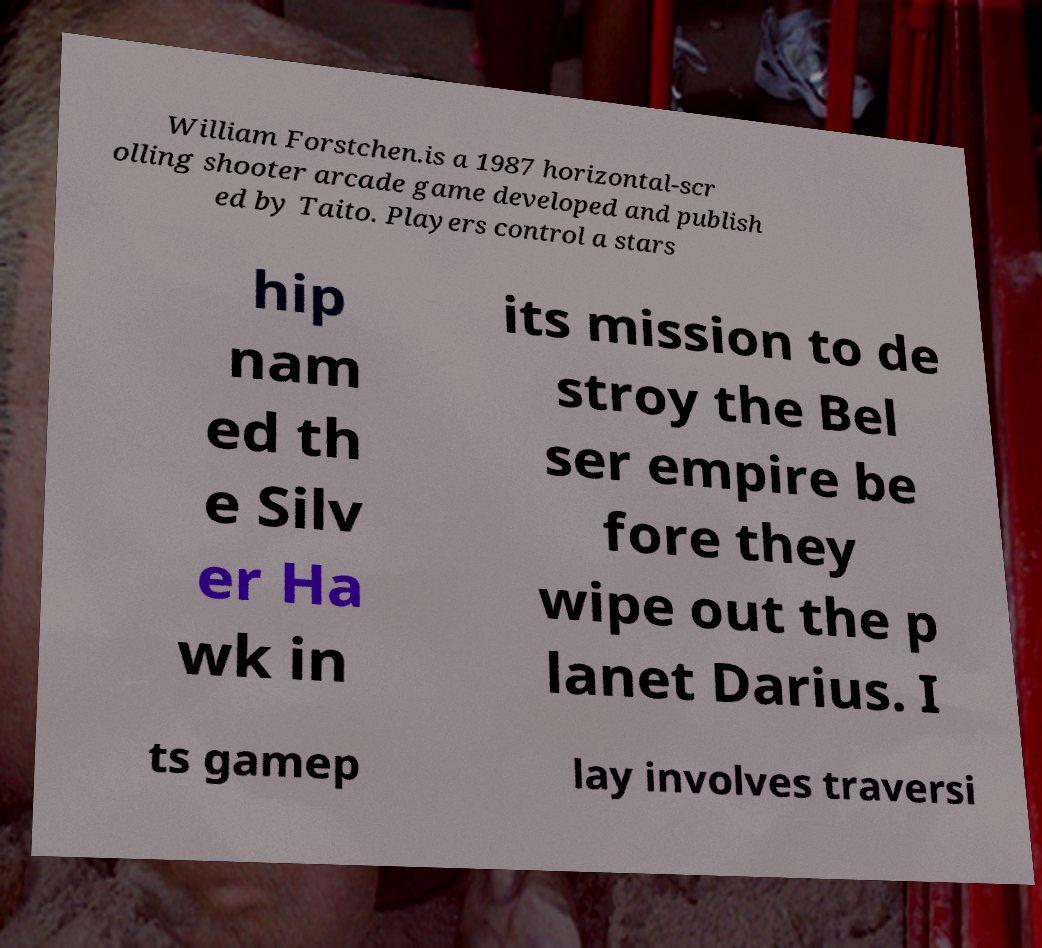Could you extract and type out the text from this image? William Forstchen.is a 1987 horizontal-scr olling shooter arcade game developed and publish ed by Taito. Players control a stars hip nam ed th e Silv er Ha wk in its mission to de stroy the Bel ser empire be fore they wipe out the p lanet Darius. I ts gamep lay involves traversi 